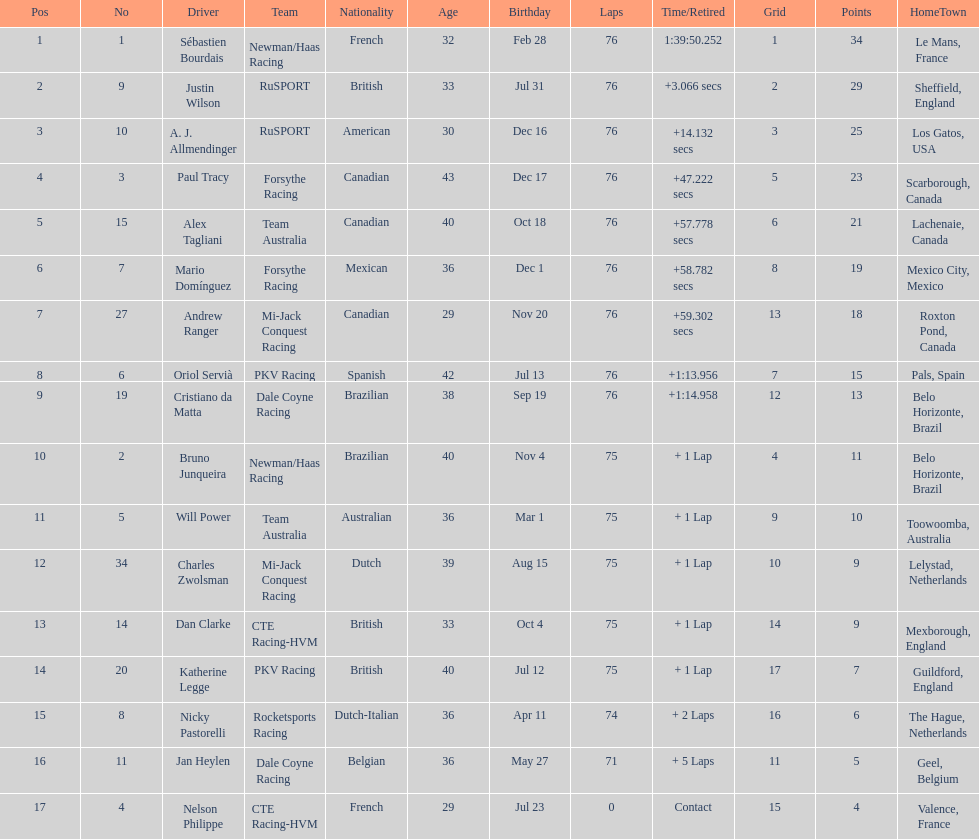I'm looking to parse the entire table for insights. Could you assist me with that? {'header': ['Pos', 'No', 'Driver', 'Team', 'Nationality', 'Age', 'Birthday', 'Laps', 'Time/Retired', 'Grid', 'Points', 'HomeTown'], 'rows': [['1', '1', 'Sébastien Bourdais', 'Newman/Haas Racing', 'French', '32', 'Feb 28', '76', '1:39:50.252', '1', '34', 'Le Mans, France'], ['2', '9', 'Justin Wilson', 'RuSPORT', 'British', '33', 'Jul 31', '76', '+3.066 secs', '2', '29', 'Sheffield, England'], ['3', '10', 'A. J. Allmendinger', 'RuSPORT', 'American', '30', 'Dec 16', '76', '+14.132 secs', '3', '25', 'Los Gatos, USA'], ['4', '3', 'Paul Tracy', 'Forsythe Racing', 'Canadian', '43', 'Dec 17', '76', '+47.222 secs', '5', '23', 'Scarborough, Canada'], ['5', '15', 'Alex Tagliani', 'Team Australia', 'Canadian', '40', 'Oct 18', '76', '+57.778 secs', '6', '21', 'Lachenaie, Canada'], ['6', '7', 'Mario Domínguez', 'Forsythe Racing', 'Mexican', '36', 'Dec 1', '76', '+58.782 secs', '8', '19', 'Mexico City, Mexico'], ['7', '27', 'Andrew Ranger', 'Mi-Jack Conquest Racing', 'Canadian', '29', 'Nov 20', '76', '+59.302 secs', '13', '18', 'Roxton Pond, Canada'], ['8', '6', 'Oriol Servià', 'PKV Racing', 'Spanish', '42', 'Jul 13', '76', '+1:13.956', '7', '15', 'Pals, Spain'], ['9', '19', 'Cristiano da Matta', 'Dale Coyne Racing', 'Brazilian', '38', 'Sep 19', '76', '+1:14.958', '12', '13', 'Belo Horizonte, Brazil'], ['10', '2', 'Bruno Junqueira', 'Newman/Haas Racing', 'Brazilian', '40', 'Nov 4', '75', '+ 1 Lap', '4', '11', 'Belo Horizonte, Brazil'], ['11', '5', 'Will Power', 'Team Australia', 'Australian', '36', 'Mar 1', '75', '+ 1 Lap', '9', '10', 'Toowoomba, Australia'], ['12', '34', 'Charles Zwolsman', 'Mi-Jack Conquest Racing', 'Dutch', '39', 'Aug 15', '75', '+ 1 Lap', '10', '9', 'Lelystad, Netherlands'], ['13', '14', 'Dan Clarke', 'CTE Racing-HVM', 'British', '33', 'Oct 4', '75', '+ 1 Lap', '14', '9', 'Mexborough, England'], ['14', '20', 'Katherine Legge', 'PKV Racing', 'British', '40', 'Jul 12', '75', '+ 1 Lap', '17', '7', 'Guildford, England'], ['15', '8', 'Nicky Pastorelli', 'Rocketsports Racing', 'Dutch-Italian', '36', 'Apr 11', '74', '+ 2 Laps', '16', '6', 'The Hague, Netherlands'], ['16', '11', 'Jan Heylen', 'Dale Coyne Racing', 'Belgian', '36', 'May 27', '71', '+ 5 Laps', '11', '5', 'Geel, Belgium'], ['17', '4', 'Nelson Philippe', 'CTE Racing-HVM', 'French', '29', 'Jul 23', '0', 'Contact', '15', '4', 'Valence, France']]} How many positions are held by canada? 3. 